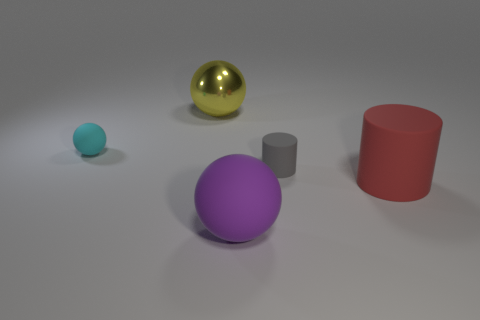What is the size of the other rubber thing that is the same shape as the tiny gray rubber object?
Provide a succinct answer. Large. Are there any cyan spheres behind the cyan ball?
Give a very brief answer. No. What is the material of the gray thing?
Keep it short and to the point. Rubber. Is the color of the sphere left of the yellow ball the same as the big rubber cylinder?
Provide a short and direct response. No. Is there any other thing that is the same shape as the large purple rubber object?
Offer a very short reply. Yes. There is a small matte thing that is the same shape as the large metallic thing; what is its color?
Give a very brief answer. Cyan. There is a small thing that is to the left of the big yellow object; what material is it?
Keep it short and to the point. Rubber. The tiny cylinder is what color?
Ensure brevity in your answer.  Gray. Does the thing that is behind the cyan object have the same size as the large red matte thing?
Keep it short and to the point. Yes. What material is the sphere that is to the left of the large object on the left side of the large ball that is in front of the gray matte object?
Your answer should be very brief. Rubber. 